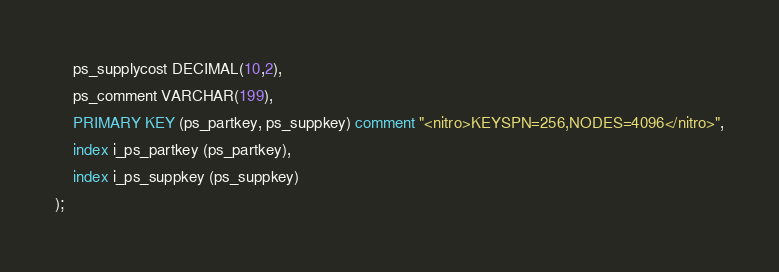<code> <loc_0><loc_0><loc_500><loc_500><_SQL_>	ps_supplycost DECIMAL(10,2),
	ps_comment VARCHAR(199),
	PRIMARY KEY (ps_partkey, ps_suppkey) comment "<nitro>KEYSPN=256,NODES=4096</nitro>",
	index i_ps_partkey (ps_partkey),
	index i_ps_suppkey (ps_suppkey)
);
</code> 